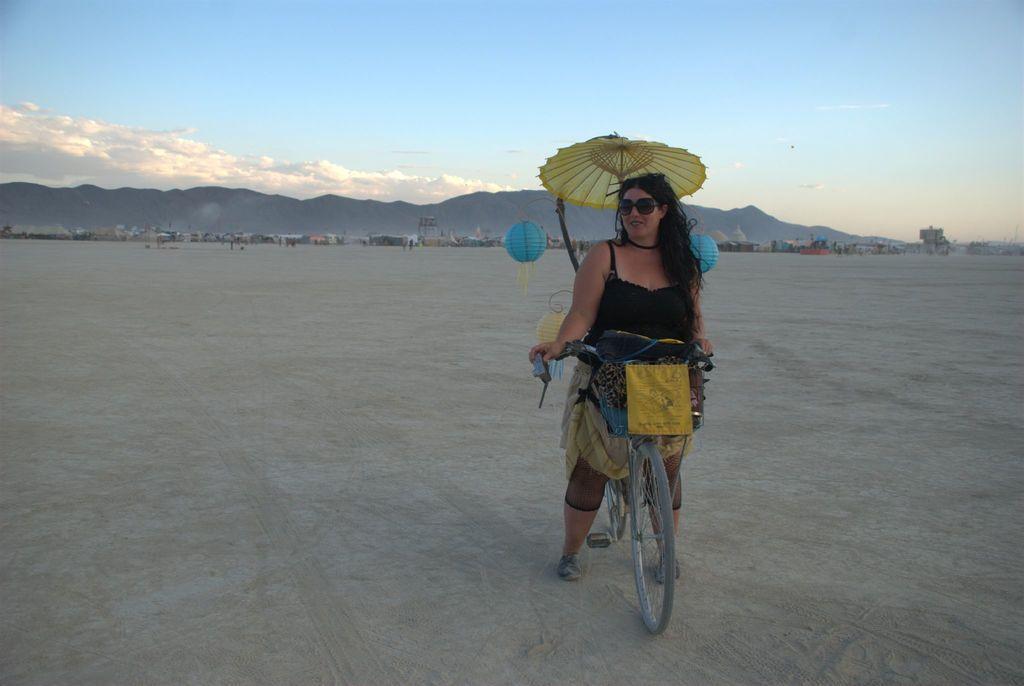Please provide a concise description of this image. There is a woman on the bicycle. This is an umbrella. On the background there is a sky with clouds and this is mountain. 